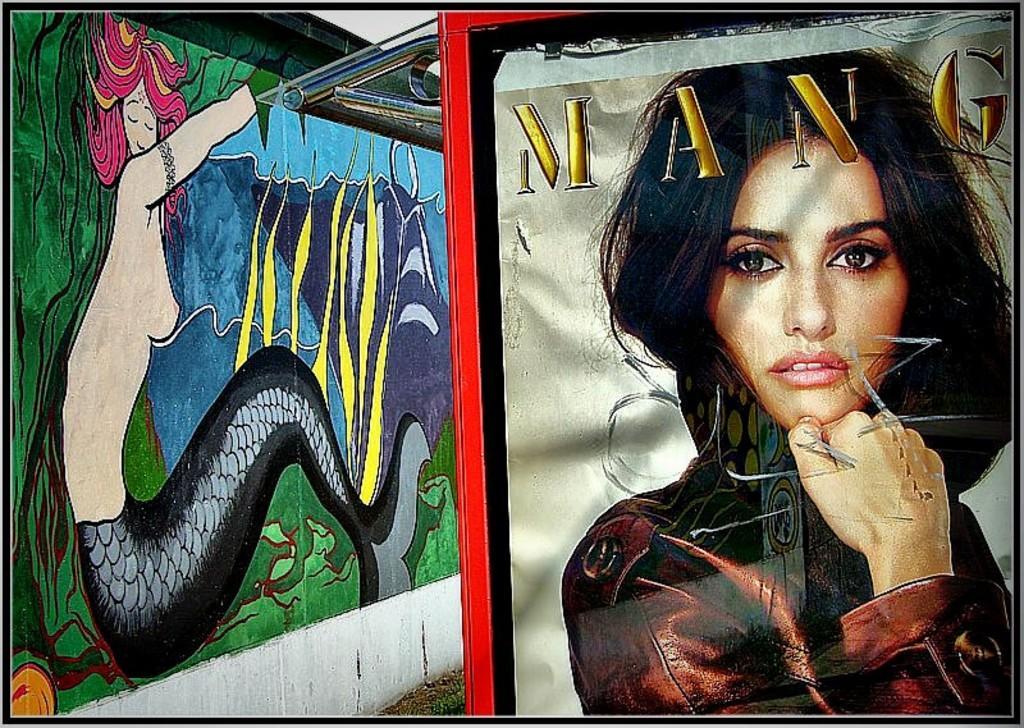Describe this image in one or two sentences. In this image I see the wall over here on which is an art of a mermaid and I see the picture of woman over here who is wearing brown dress and I see a word written over here. 